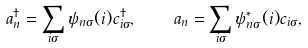Convert formula to latex. <formula><loc_0><loc_0><loc_500><loc_500>a ^ { \dagger } _ { n } = \sum _ { i \sigma } \psi _ { n \sigma } ( i ) c ^ { \dagger } _ { i \sigma } , \quad a _ { n } = \sum _ { i \sigma } \psi ^ { * } _ { n \sigma } ( i ) c _ { i \sigma } ,</formula> 